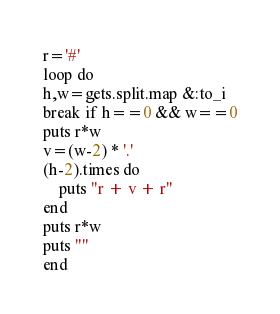<code> <loc_0><loc_0><loc_500><loc_500><_Ruby_>r='#'
loop do
h,w=gets.split.map &:to_i
break if h==0 && w==0
puts r*w
v=(w-2) * '.'
(h-2).times do 
    puts "r + v + r"
end
puts r*w
puts ""
end
</code> 